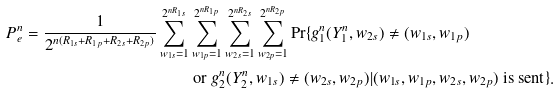Convert formula to latex. <formula><loc_0><loc_0><loc_500><loc_500>P _ { e } ^ { n } = \frac { 1 } { 2 ^ { n ( R _ { 1 s } + R _ { 1 p } + R _ { 2 s } + R _ { 2 p } ) } } \sum _ { w _ { 1 s } = 1 } ^ { 2 ^ { n R _ { 1 s } } } & \sum _ { w _ { 1 p } = 1 } ^ { 2 ^ { n R _ { 1 p } } } \sum _ { w _ { 2 s } = 1 } ^ { 2 ^ { n R _ { 2 s } } } \sum _ { w _ { 2 p } = 1 } ^ { 2 ^ { n R _ { 2 p } } } \text {Pr} \{ g _ { 1 } ^ { n } ( Y _ { 1 } ^ { n } , w _ { 2 s } ) \neq ( w _ { 1 s } , w _ { 1 p } ) \\ & \text { or } g _ { 2 } ^ { n } ( Y _ { 2 } ^ { n } , w _ { 1 s } ) \neq ( w _ { 2 s } , w _ { 2 p } ) | ( w _ { 1 s } , w _ { 1 p } , w _ { 2 s } , w _ { 2 p } ) \text { is sent} \} .</formula> 